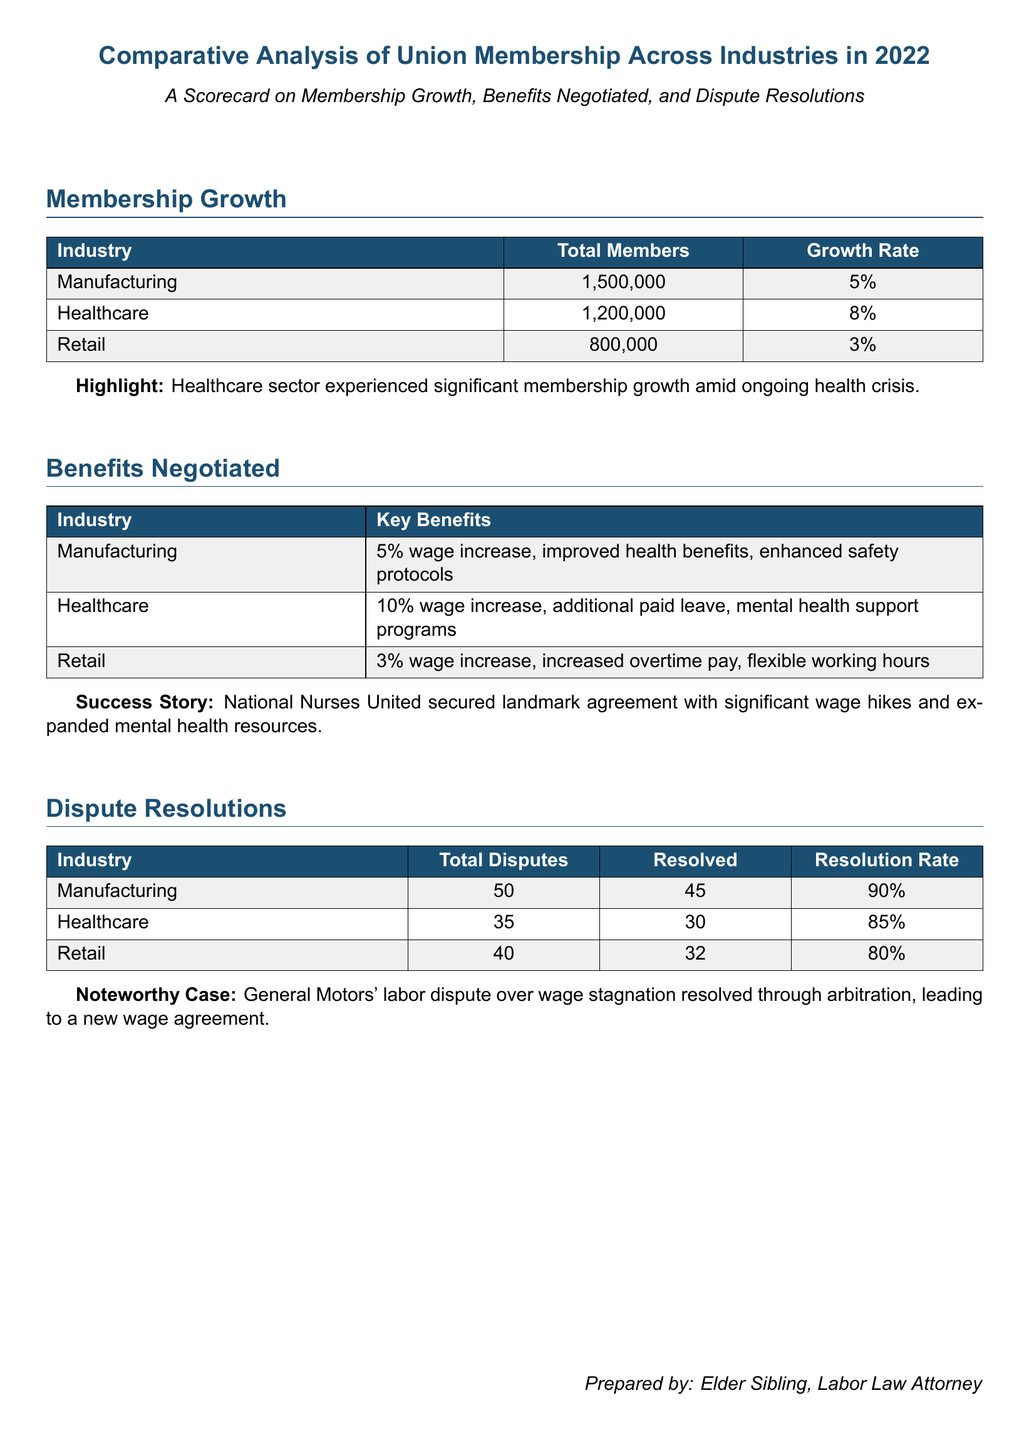What is the total number of union members in the Manufacturing industry? The total number of union members in Manufacturing is explicitly stated in the document.
Answer: 1,500,000 Which industry had the highest growth rate in 2022? The growth rate for each industry is listed in the document, making it easy to compare them.
Answer: Healthcare What percentage of disputes were resolved in the Retail industry? The resolution rate for Retail is provided in the Dispute Resolutions section.
Answer: 80% How many key benefits were negotiated for the Healthcare industry? The document lists the key benefits for each industry, allowing for direct counting.
Answer: 3 What significant achievement did National Nurses United secure? The success story highlights a specific agreement that illustrates the benefits gained in the Healthcare sector.
Answer: Landmark agreement What was the total number of disputes in the Manufacturing industry? This information is found in the table outlining dispute resolutions categorized by industry.
Answer: 50 What is the percentage increase in wages negotiated for the Healthcare sector? The benefits negotiated for the Healthcare industry include specific wage increases.
Answer: 10% Which industry has the lowest membership growth rate? The growth rates for each industry are provided for comparison in the membership growth section.
Answer: Retail 